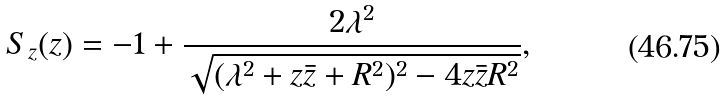Convert formula to latex. <formula><loc_0><loc_0><loc_500><loc_500>S _ { z } ( z ) = - 1 + \frac { 2 \lambda ^ { 2 } } { \sqrt { ( \lambda ^ { 2 } + z \bar { z } + R ^ { 2 } ) ^ { 2 } - 4 z \bar { z } R ^ { 2 } } } ,</formula> 